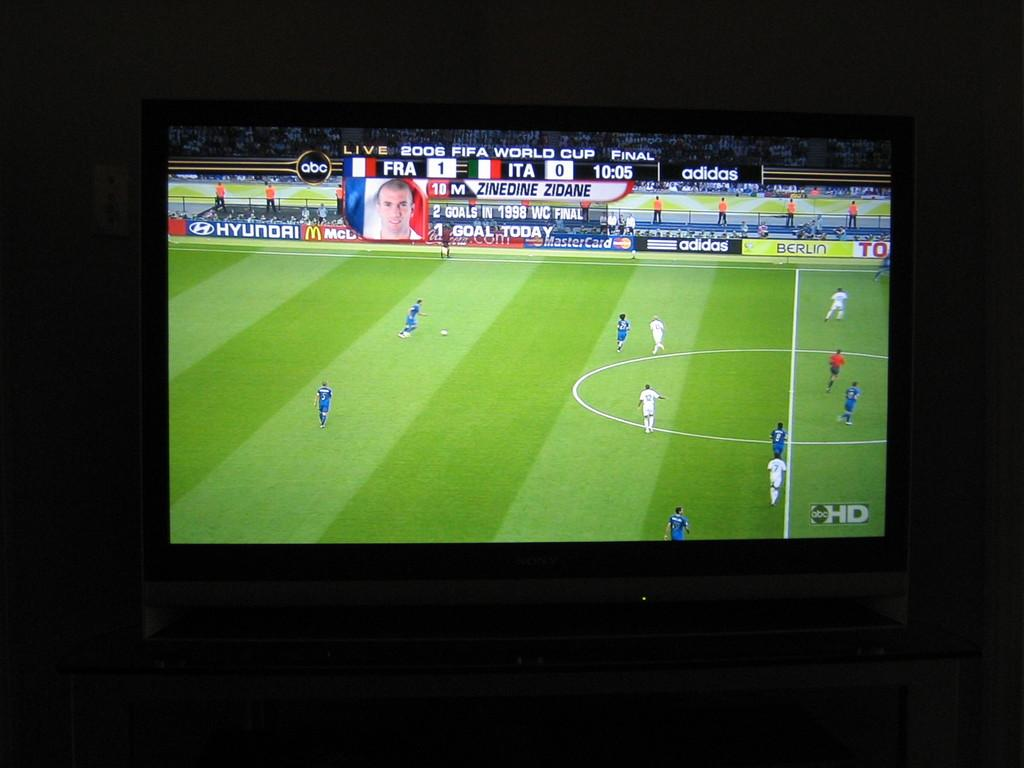<image>
Provide a brief description of the given image. A television shows a soccer game with the banner 2006 Fifa World Cup. 